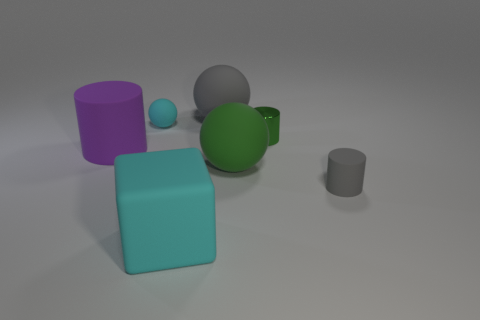Add 1 large cyan matte blocks. How many objects exist? 8 Subtract all balls. How many objects are left? 4 Add 3 large purple shiny cylinders. How many large purple shiny cylinders exist? 3 Subtract 0 brown blocks. How many objects are left? 7 Subtract all cyan things. Subtract all cyan blocks. How many objects are left? 4 Add 2 small objects. How many small objects are left? 5 